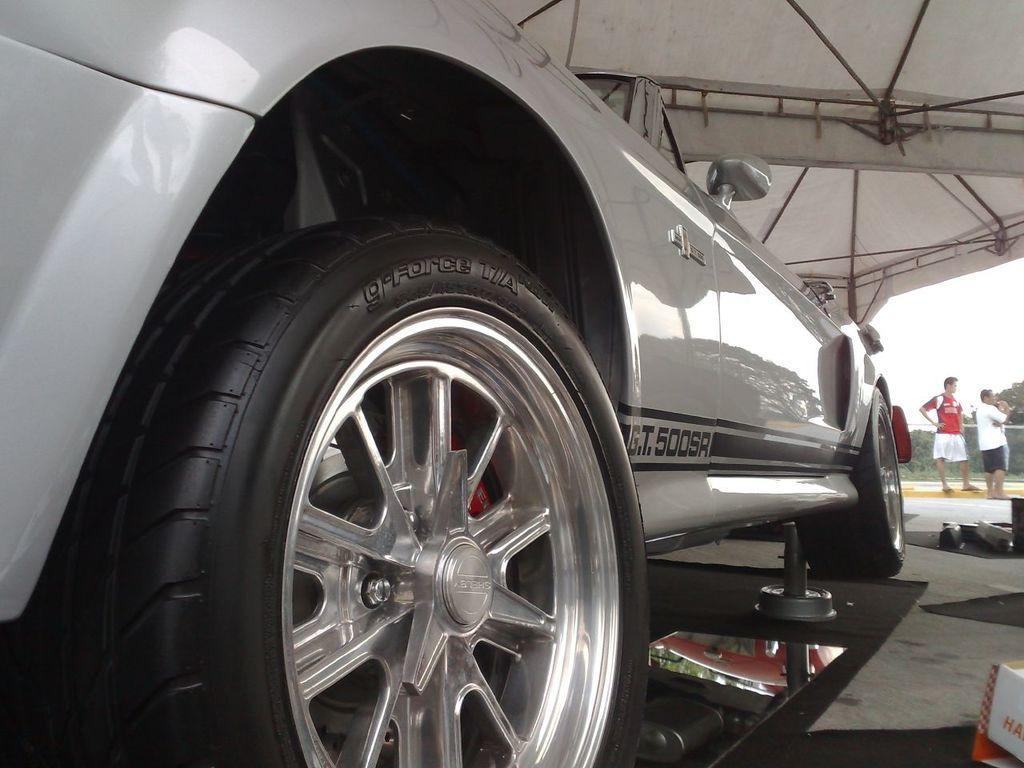Could you give a brief overview of what you see in this image? This image is taken outdoors. On the left side of the image a car is parked on the floor. On the right side of the image there is a cardboard box and a few things on the floor. Two men are standing on the floor. In the background there are a few trees. At the top of the image there is a tent and there are a few iron bars. 